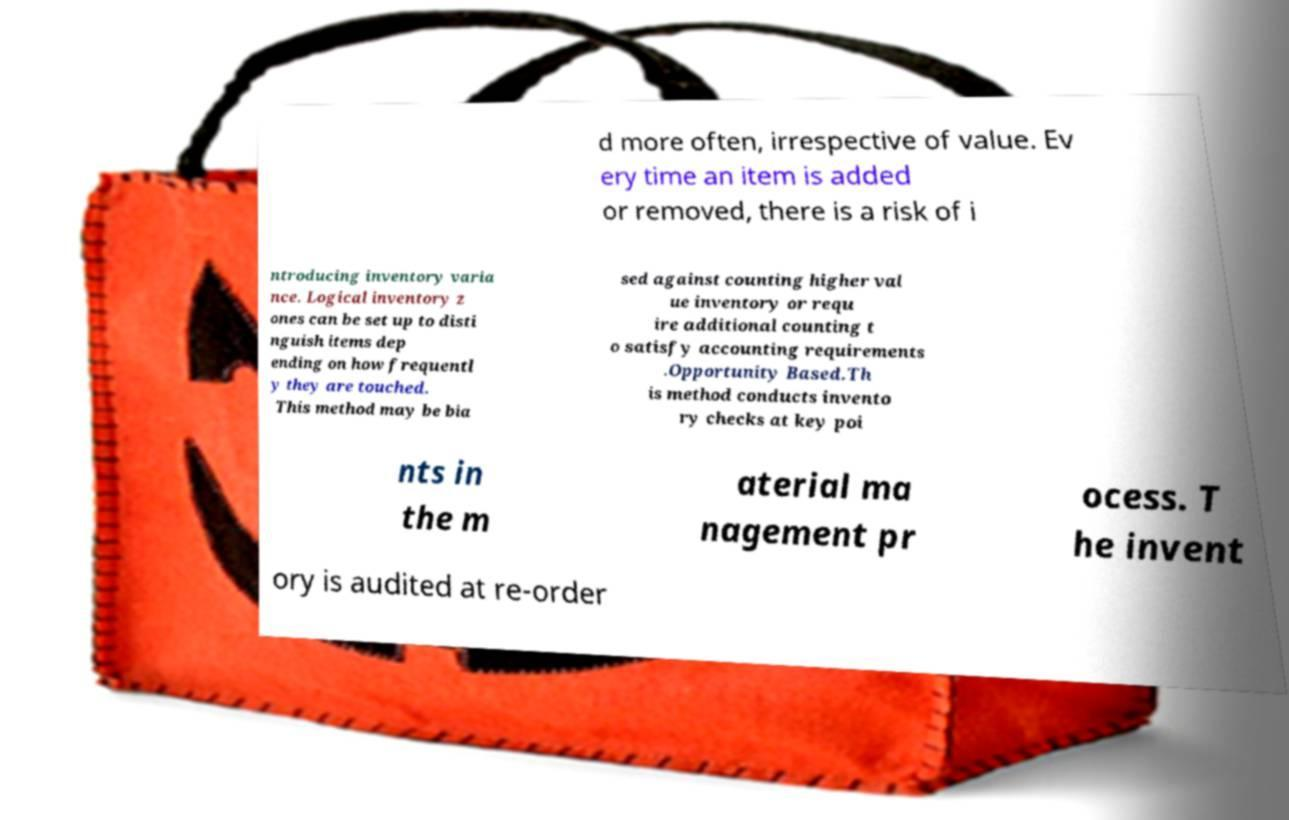For documentation purposes, I need the text within this image transcribed. Could you provide that? d more often, irrespective of value. Ev ery time an item is added or removed, there is a risk of i ntroducing inventory varia nce. Logical inventory z ones can be set up to disti nguish items dep ending on how frequentl y they are touched. This method may be bia sed against counting higher val ue inventory or requ ire additional counting t o satisfy accounting requirements .Opportunity Based.Th is method conducts invento ry checks at key poi nts in the m aterial ma nagement pr ocess. T he invent ory is audited at re-order 